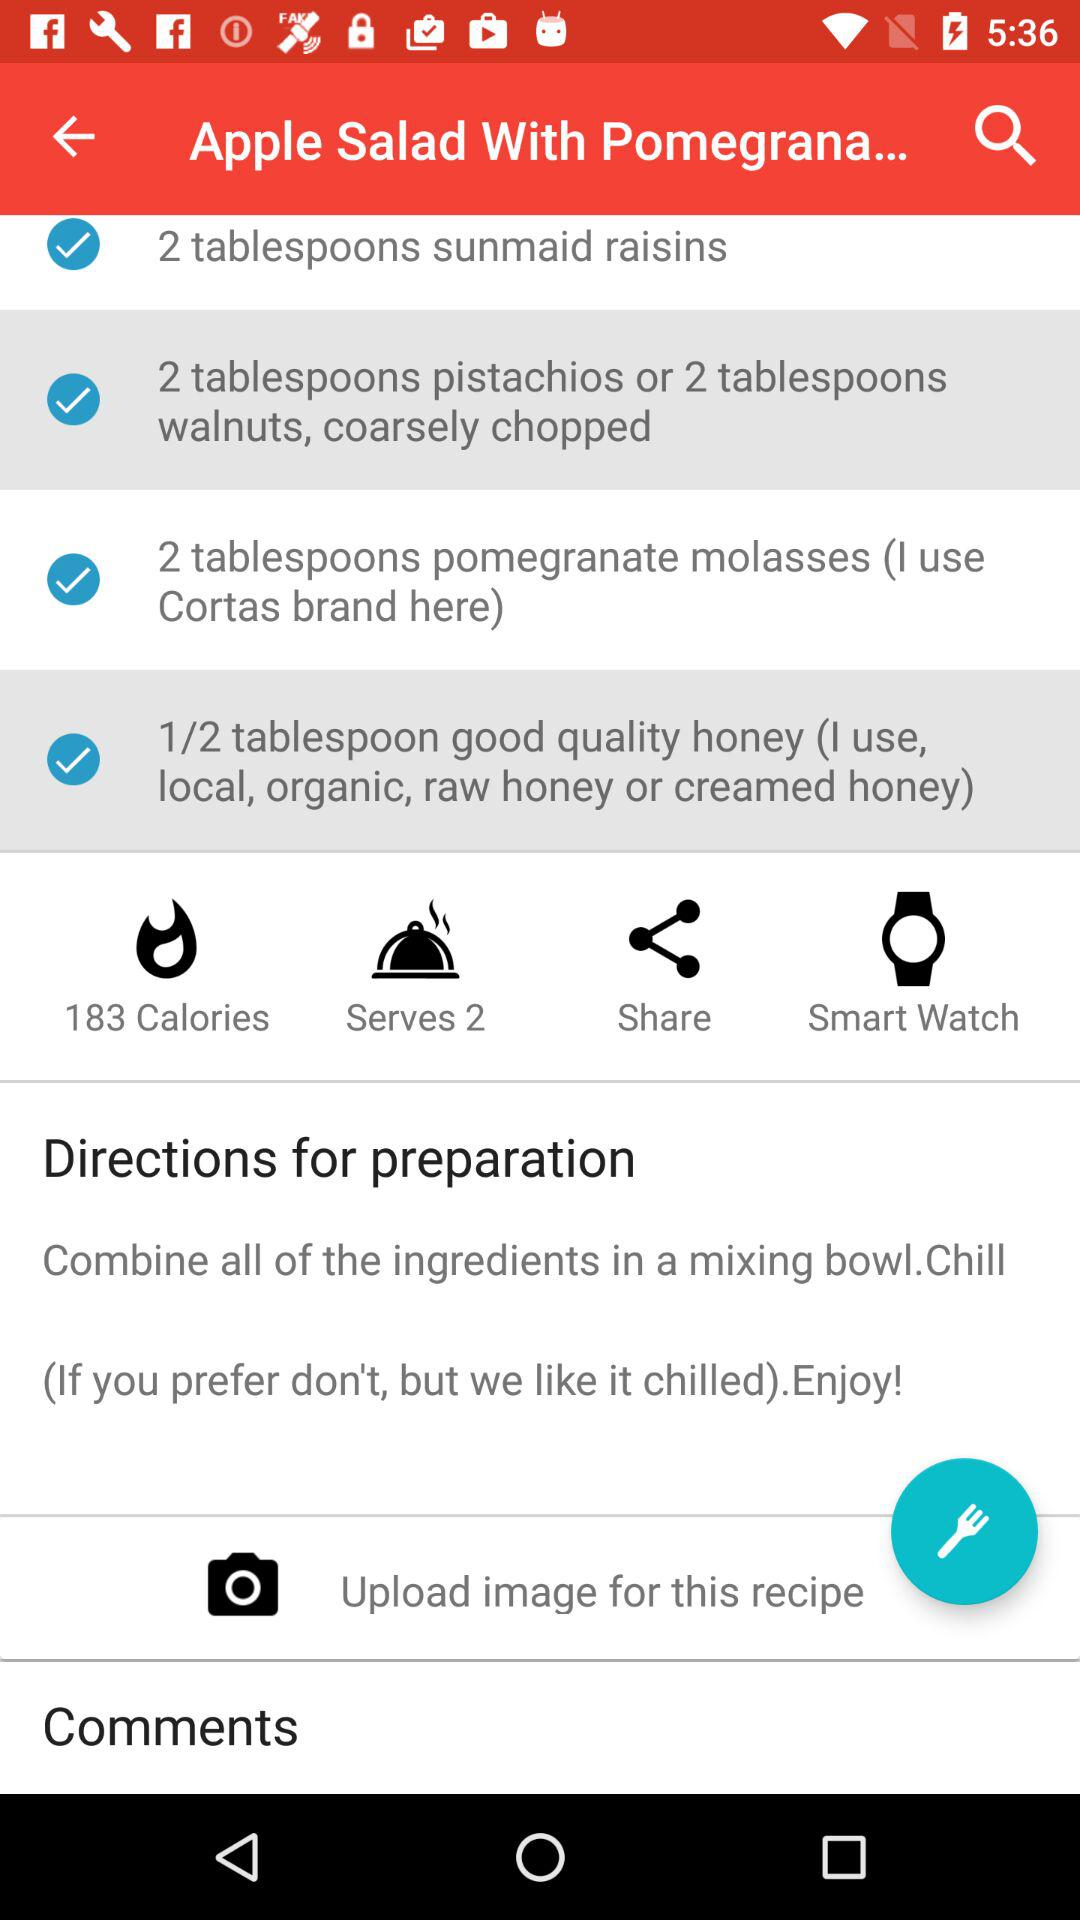How many people can the salad be served to? The salad can be served to 2 people. 